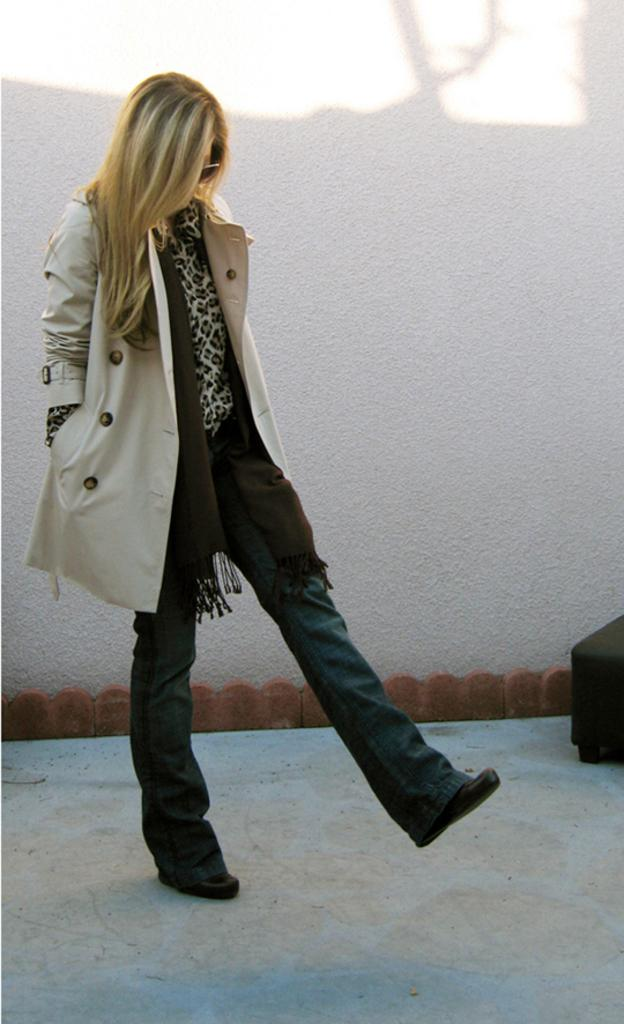Who is the main subject in the image? There is a lady in the image. What is the lady wearing on her face? The lady is wearing goggles. What can be seen in the background of the image? There is a wall in the background of the image. What color is the object on the right side of the image? The object on the right side of the image is black. What type of donkey can be seen interacting with the lady in the image? There is no donkey present in the image; the lady is the main subject. What team does the lady belong to in the image? There is no indication of a team in the image; it simply features a lady wearing goggles. 